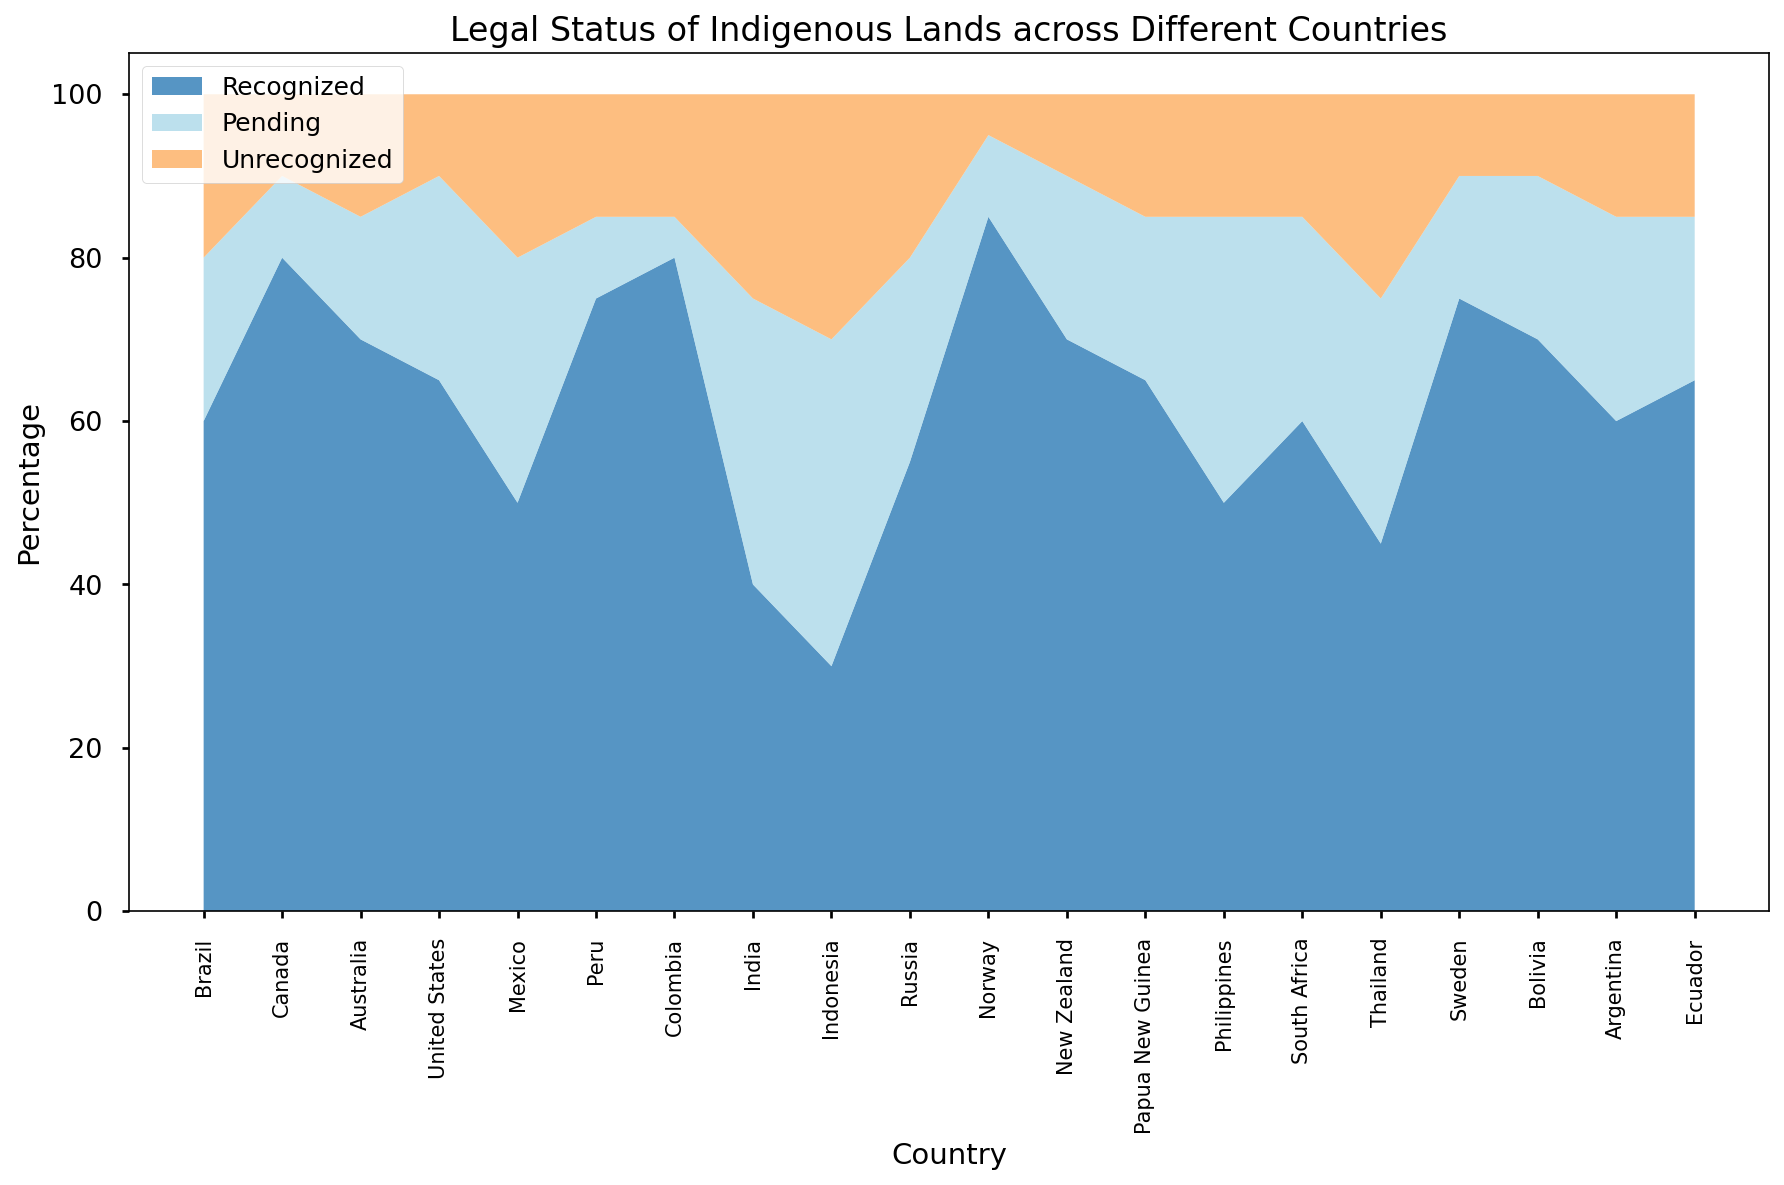What country has the highest percentage of recognized indigenous lands? By looking at the figure, we can observe the section with the blue color and identify the country with the tallest blue section. Norway has the highest blue section, indicating the highest percentage of recognized indigenous lands.
Answer: Norway Which country has the smallest percentage of unrecognized indigenous lands? The unrecognized lands are represented by the orange section. By identifying the country with the smallest orange section, we can determine that Norway has the smallest percentage of unrecognized lands.
Answer: Norway Compare the percentage of recognized indigenous lands between Canada and Indonesia. We need to look at the blue sections for both Canada and Indonesia. Canada's blue section is taller than Indonesia's blue section, indicating that Canada has a higher percentage of recognized indigenous lands.
Answer: Canada What is the combined percentage of pending and unrecognized indigenous lands in Mexico? The pending and unrecognized lands are represented by the lighter blue and orange sections respectively. Adding these sections for Mexico, we get 30% (pending) + 20% (unrecognized) = 50%.
Answer: 50% Compare the total percentage of indigenous lands (both recognized and pending) between Brazil and the United States. For Brazil, the total is the sum of the blue (recognized) and light blue (pending) sections: 60% + 20% = 80%. For the United States, it is 65% + 25% = 90%. The United States has a higher total percentage of indigenous lands (recognized + pending) compared to Brazil.
Answer: The United States Which country has a higher percentage of pending indigenous lands: India or Thailand? We need to look at the light blue section of both countries. India has a higher light blue section (35%) compared to Thailand (30%).
Answer: India What is the difference in the percentage of recognized indigenous lands between Peru and Ecuador? The recognized indigenous lands are represented by the blue section. For Peru, it is 75%, and for Ecuador, it is 65%. The difference is 75% - 65% = 10%.
Answer: 10% What is the percentage of unrecognized indigenous lands in Papua New Guinea, and how does it compare to South Africa? Unrecognized indigenous lands are represented by the orange section. For Papua New Guinea, it is 15%, and for South Africa, it is also represented by 15%. Therefore, the percentages are equal.
Answer: Equal Which country has the second highest percentage of recognized indigenous lands? We need to identify the country with the second tallest blue section. Canada has the highest, followed by Colombia with a slightly shorter blue section, indicating that Colombia has the second highest percentage.
Answer: Colombia How does the percentage of pending indigenous lands in Russia compare to that in Brazil? The pending indigenous lands are represented by the light blue section. For Russia, it is 25%, and for Brazil, it is 20%. Therefore, Russia has a higher percentage of pending indigenous lands.
Answer: Russia 